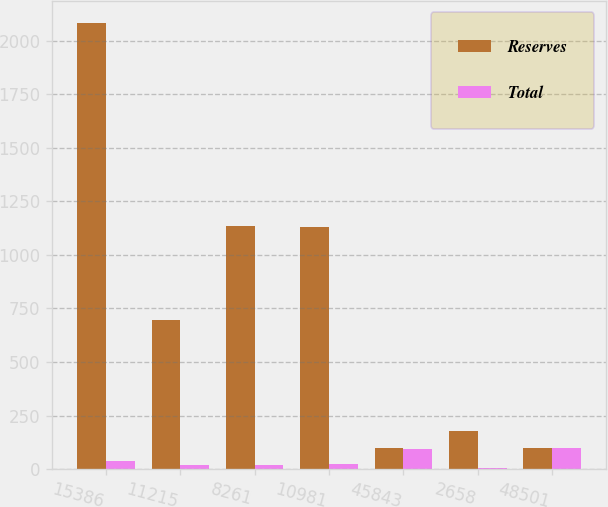Convert chart to OTSL. <chart><loc_0><loc_0><loc_500><loc_500><stacked_bar_chart><ecel><fcel>15386<fcel>11215<fcel>8261<fcel>10981<fcel>45843<fcel>2658<fcel>48501<nl><fcel>Reserves<fcel>2082.6<fcel>695.3<fcel>1135.9<fcel>1128.1<fcel>97.8<fcel>177.1<fcel>97.8<nl><fcel>Total<fcel>36<fcel>18<fcel>19.5<fcel>22.1<fcel>95.6<fcel>4.4<fcel>100<nl></chart> 